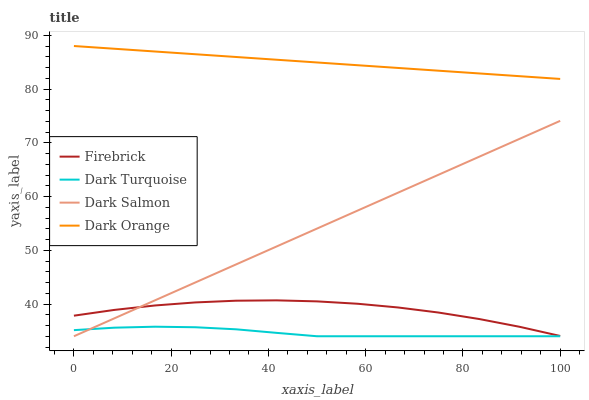Does Dark Turquoise have the minimum area under the curve?
Answer yes or no. Yes. Does Dark Orange have the maximum area under the curve?
Answer yes or no. Yes. Does Firebrick have the minimum area under the curve?
Answer yes or no. No. Does Firebrick have the maximum area under the curve?
Answer yes or no. No. Is Dark Orange the smoothest?
Answer yes or no. Yes. Is Firebrick the roughest?
Answer yes or no. Yes. Is Dark Salmon the smoothest?
Answer yes or no. No. Is Dark Salmon the roughest?
Answer yes or no. No. Does Dark Turquoise have the lowest value?
Answer yes or no. Yes. Does Firebrick have the lowest value?
Answer yes or no. No. Does Dark Orange have the highest value?
Answer yes or no. Yes. Does Firebrick have the highest value?
Answer yes or no. No. Is Dark Turquoise less than Dark Orange?
Answer yes or no. Yes. Is Firebrick greater than Dark Turquoise?
Answer yes or no. Yes. Does Dark Salmon intersect Firebrick?
Answer yes or no. Yes. Is Dark Salmon less than Firebrick?
Answer yes or no. No. Is Dark Salmon greater than Firebrick?
Answer yes or no. No. Does Dark Turquoise intersect Dark Orange?
Answer yes or no. No. 